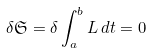<formula> <loc_0><loc_0><loc_500><loc_500>\delta \mathfrak { S } = \delta \int ^ { b } _ { a } L \, d t = 0</formula> 